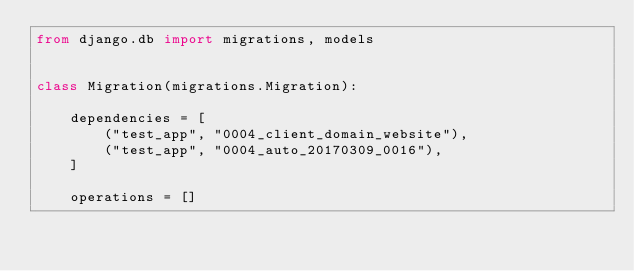<code> <loc_0><loc_0><loc_500><loc_500><_Python_>from django.db import migrations, models


class Migration(migrations.Migration):

    dependencies = [
        ("test_app", "0004_client_domain_website"),
        ("test_app", "0004_auto_20170309_0016"),
    ]

    operations = []
</code> 